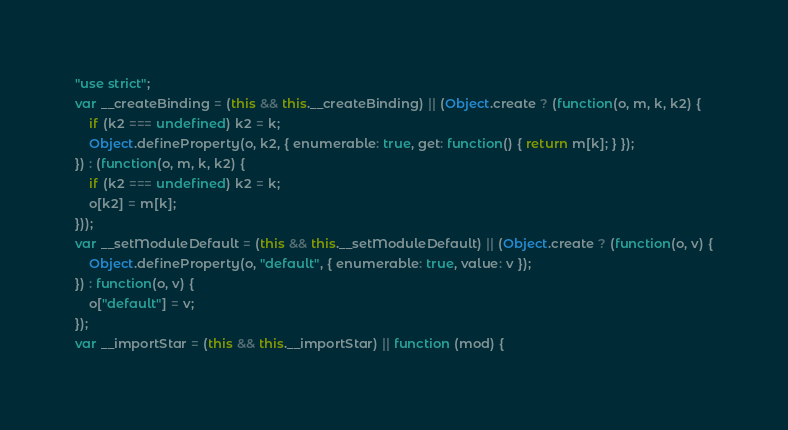Convert code to text. <code><loc_0><loc_0><loc_500><loc_500><_JavaScript_>"use strict";
var __createBinding = (this && this.__createBinding) || (Object.create ? (function(o, m, k, k2) {
    if (k2 === undefined) k2 = k;
    Object.defineProperty(o, k2, { enumerable: true, get: function() { return m[k]; } });
}) : (function(o, m, k, k2) {
    if (k2 === undefined) k2 = k;
    o[k2] = m[k];
}));
var __setModuleDefault = (this && this.__setModuleDefault) || (Object.create ? (function(o, v) {
    Object.defineProperty(o, "default", { enumerable: true, value: v });
}) : function(o, v) {
    o["default"] = v;
});
var __importStar = (this && this.__importStar) || function (mod) {</code> 